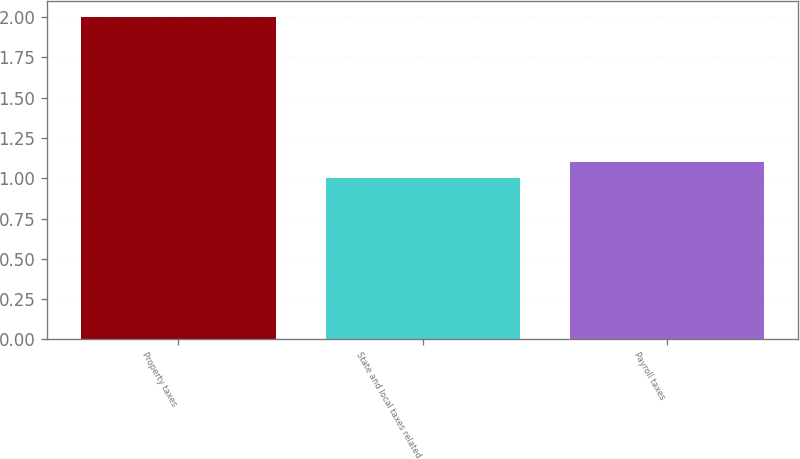Convert chart to OTSL. <chart><loc_0><loc_0><loc_500><loc_500><bar_chart><fcel>Property taxes<fcel>State and local taxes related<fcel>Payroll taxes<nl><fcel>2<fcel>1<fcel>1.1<nl></chart> 